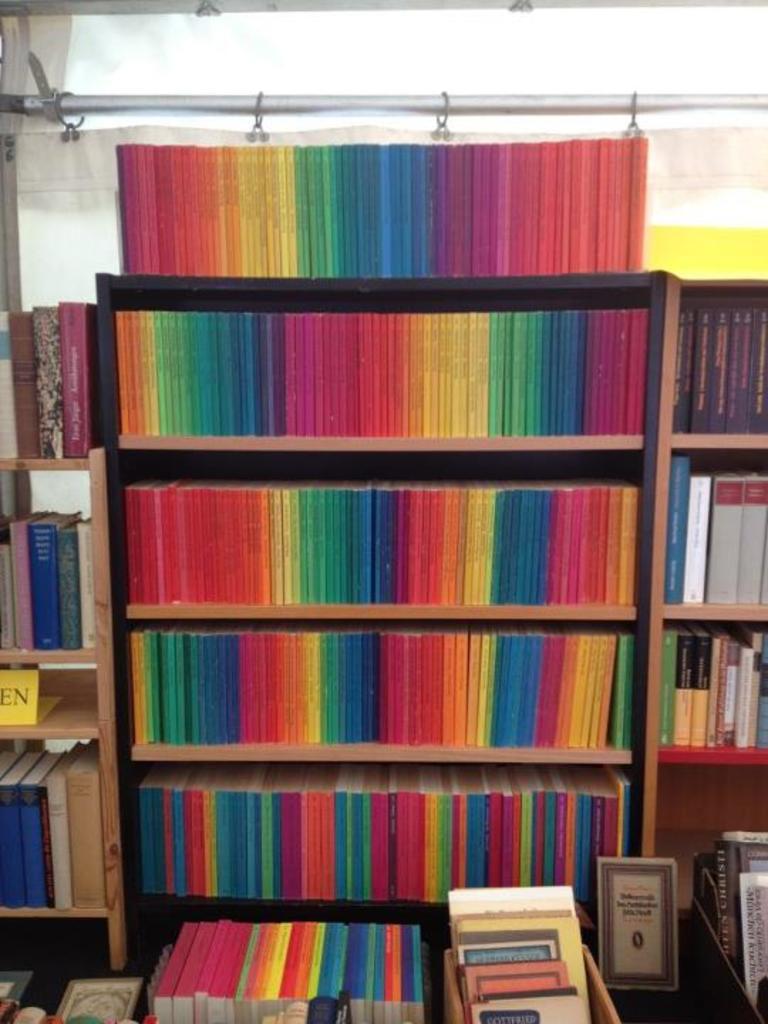How would you summarize this image in a sentence or two? In this picture we can see books, board and objects on the platform. We can see books and board in wooden racks. In the background of the image we can see curtain and rod. 